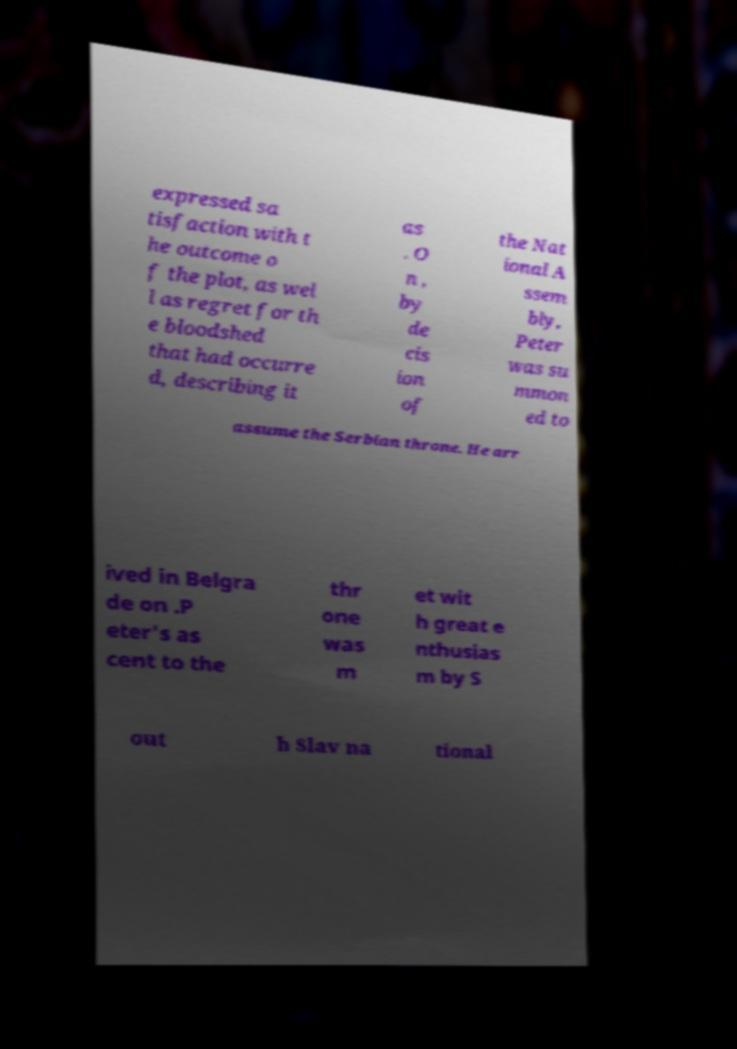Could you assist in decoding the text presented in this image and type it out clearly? expressed sa tisfaction with t he outcome o f the plot, as wel l as regret for th e bloodshed that had occurre d, describing it as . O n , by de cis ion of the Nat ional A ssem bly, Peter was su mmon ed to assume the Serbian throne. He arr ived in Belgra de on .P eter's as cent to the thr one was m et wit h great e nthusias m by S out h Slav na tional 